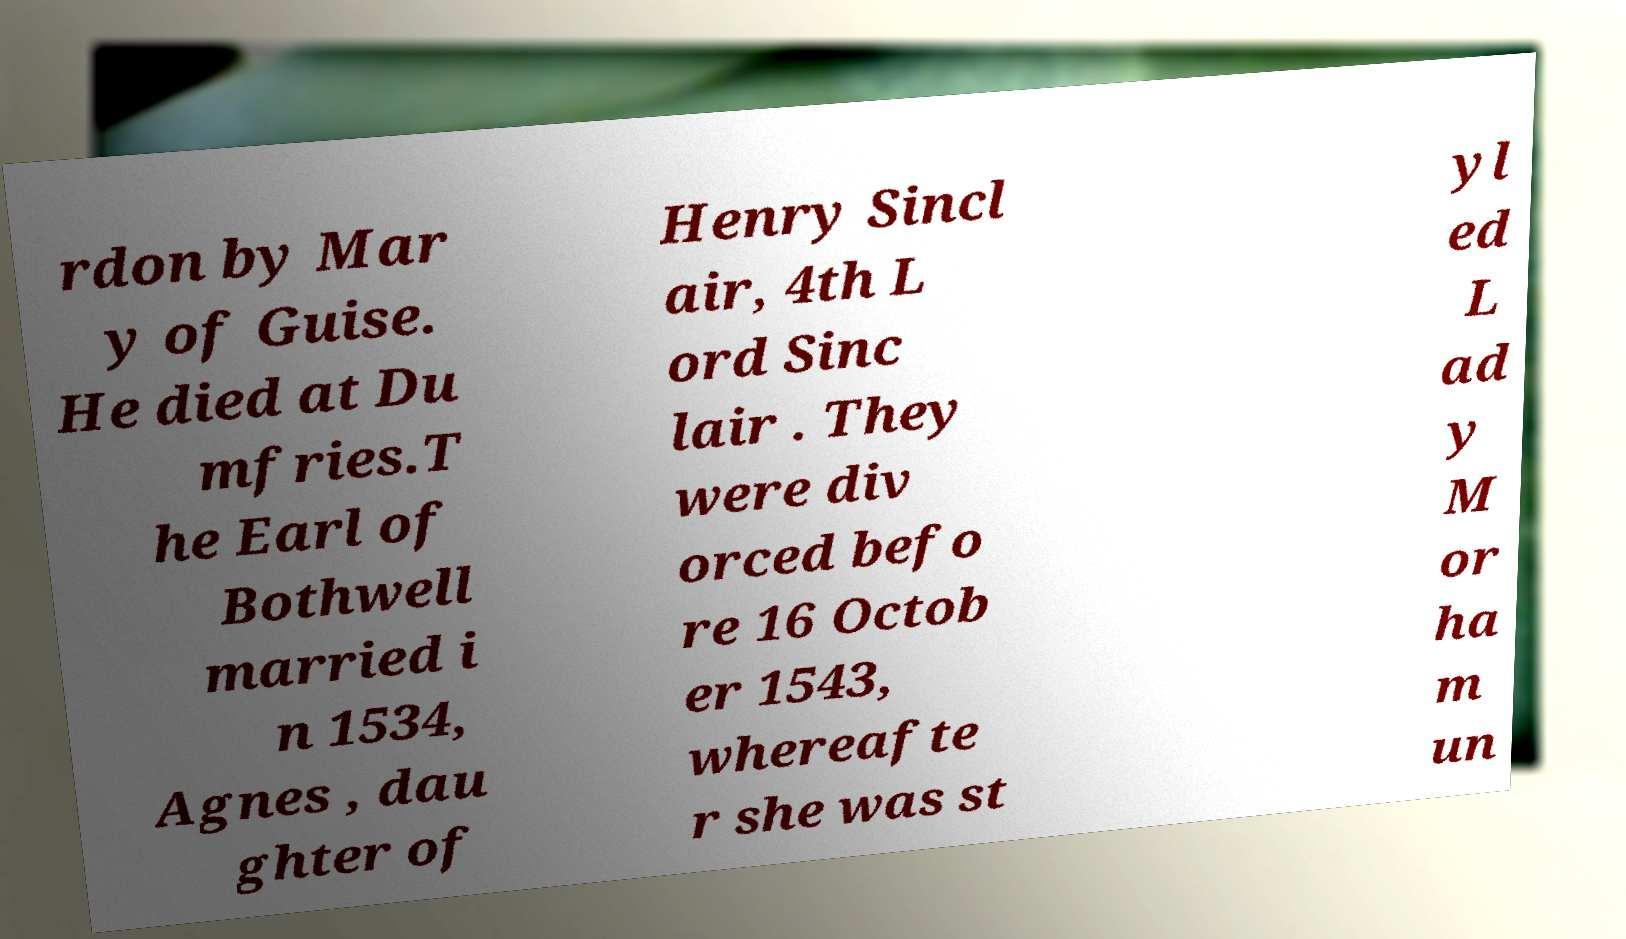Could you assist in decoding the text presented in this image and type it out clearly? rdon by Mar y of Guise. He died at Du mfries.T he Earl of Bothwell married i n 1534, Agnes , dau ghter of Henry Sincl air, 4th L ord Sinc lair . They were div orced befo re 16 Octob er 1543, whereafte r she was st yl ed L ad y M or ha m un 